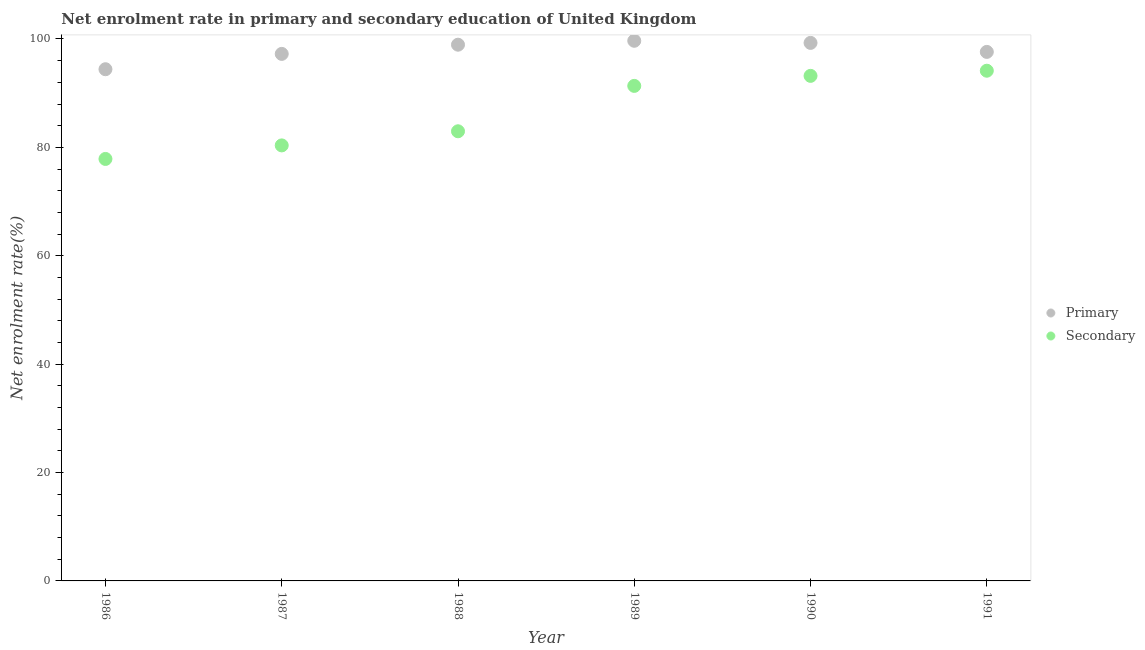How many different coloured dotlines are there?
Make the answer very short. 2. What is the enrollment rate in primary education in 1986?
Your response must be concise. 94.42. Across all years, what is the maximum enrollment rate in secondary education?
Give a very brief answer. 94.14. Across all years, what is the minimum enrollment rate in secondary education?
Keep it short and to the point. 77.86. What is the total enrollment rate in secondary education in the graph?
Provide a succinct answer. 519.88. What is the difference between the enrollment rate in secondary education in 1986 and that in 1988?
Keep it short and to the point. -5.11. What is the difference between the enrollment rate in secondary education in 1988 and the enrollment rate in primary education in 1991?
Offer a very short reply. -14.65. What is the average enrollment rate in secondary education per year?
Give a very brief answer. 86.65. In the year 1990, what is the difference between the enrollment rate in secondary education and enrollment rate in primary education?
Your response must be concise. -6.08. In how many years, is the enrollment rate in secondary education greater than 92 %?
Provide a short and direct response. 2. What is the ratio of the enrollment rate in secondary education in 1988 to that in 1989?
Offer a terse response. 0.91. Is the enrollment rate in secondary education in 1988 less than that in 1991?
Your answer should be very brief. Yes. Is the difference between the enrollment rate in primary education in 1988 and 1990 greater than the difference between the enrollment rate in secondary education in 1988 and 1990?
Your answer should be compact. Yes. What is the difference between the highest and the second highest enrollment rate in secondary education?
Give a very brief answer. 0.95. What is the difference between the highest and the lowest enrollment rate in secondary education?
Make the answer very short. 16.28. In how many years, is the enrollment rate in primary education greater than the average enrollment rate in primary education taken over all years?
Provide a succinct answer. 3. Is the sum of the enrollment rate in primary education in 1986 and 1987 greater than the maximum enrollment rate in secondary education across all years?
Offer a terse response. Yes. Is the enrollment rate in primary education strictly greater than the enrollment rate in secondary education over the years?
Provide a short and direct response. Yes. Is the enrollment rate in primary education strictly less than the enrollment rate in secondary education over the years?
Your answer should be compact. No. Does the graph contain grids?
Keep it short and to the point. No. Where does the legend appear in the graph?
Provide a short and direct response. Center right. What is the title of the graph?
Give a very brief answer. Net enrolment rate in primary and secondary education of United Kingdom. Does "Merchandise exports" appear as one of the legend labels in the graph?
Your answer should be very brief. No. What is the label or title of the Y-axis?
Ensure brevity in your answer.  Net enrolment rate(%). What is the Net enrolment rate(%) in Primary in 1986?
Provide a succinct answer. 94.42. What is the Net enrolment rate(%) of Secondary in 1986?
Provide a succinct answer. 77.86. What is the Net enrolment rate(%) of Primary in 1987?
Your answer should be compact. 97.25. What is the Net enrolment rate(%) of Secondary in 1987?
Provide a succinct answer. 80.36. What is the Net enrolment rate(%) in Primary in 1988?
Keep it short and to the point. 98.95. What is the Net enrolment rate(%) in Secondary in 1988?
Provide a short and direct response. 82.97. What is the Net enrolment rate(%) in Primary in 1989?
Give a very brief answer. 99.67. What is the Net enrolment rate(%) in Secondary in 1989?
Provide a succinct answer. 91.34. What is the Net enrolment rate(%) of Primary in 1990?
Your answer should be compact. 99.28. What is the Net enrolment rate(%) in Secondary in 1990?
Provide a succinct answer. 93.19. What is the Net enrolment rate(%) of Primary in 1991?
Make the answer very short. 97.62. What is the Net enrolment rate(%) of Secondary in 1991?
Make the answer very short. 94.14. Across all years, what is the maximum Net enrolment rate(%) of Primary?
Keep it short and to the point. 99.67. Across all years, what is the maximum Net enrolment rate(%) in Secondary?
Offer a terse response. 94.14. Across all years, what is the minimum Net enrolment rate(%) of Primary?
Give a very brief answer. 94.42. Across all years, what is the minimum Net enrolment rate(%) of Secondary?
Your answer should be compact. 77.86. What is the total Net enrolment rate(%) in Primary in the graph?
Offer a terse response. 587.18. What is the total Net enrolment rate(%) of Secondary in the graph?
Provide a short and direct response. 519.88. What is the difference between the Net enrolment rate(%) in Primary in 1986 and that in 1987?
Give a very brief answer. -2.83. What is the difference between the Net enrolment rate(%) of Secondary in 1986 and that in 1987?
Your answer should be very brief. -2.5. What is the difference between the Net enrolment rate(%) in Primary in 1986 and that in 1988?
Provide a succinct answer. -4.53. What is the difference between the Net enrolment rate(%) in Secondary in 1986 and that in 1988?
Give a very brief answer. -5.11. What is the difference between the Net enrolment rate(%) of Primary in 1986 and that in 1989?
Keep it short and to the point. -5.25. What is the difference between the Net enrolment rate(%) in Secondary in 1986 and that in 1989?
Make the answer very short. -13.48. What is the difference between the Net enrolment rate(%) of Primary in 1986 and that in 1990?
Your answer should be compact. -4.86. What is the difference between the Net enrolment rate(%) in Secondary in 1986 and that in 1990?
Ensure brevity in your answer.  -15.33. What is the difference between the Net enrolment rate(%) in Primary in 1986 and that in 1991?
Provide a succinct answer. -3.2. What is the difference between the Net enrolment rate(%) of Secondary in 1986 and that in 1991?
Your response must be concise. -16.28. What is the difference between the Net enrolment rate(%) of Primary in 1987 and that in 1988?
Provide a succinct answer. -1.7. What is the difference between the Net enrolment rate(%) in Secondary in 1987 and that in 1988?
Make the answer very short. -2.61. What is the difference between the Net enrolment rate(%) of Primary in 1987 and that in 1989?
Make the answer very short. -2.42. What is the difference between the Net enrolment rate(%) of Secondary in 1987 and that in 1989?
Offer a very short reply. -10.98. What is the difference between the Net enrolment rate(%) of Primary in 1987 and that in 1990?
Give a very brief answer. -2.03. What is the difference between the Net enrolment rate(%) of Secondary in 1987 and that in 1990?
Provide a succinct answer. -12.83. What is the difference between the Net enrolment rate(%) in Primary in 1987 and that in 1991?
Your response must be concise. -0.37. What is the difference between the Net enrolment rate(%) of Secondary in 1987 and that in 1991?
Your response must be concise. -13.78. What is the difference between the Net enrolment rate(%) in Primary in 1988 and that in 1989?
Give a very brief answer. -0.72. What is the difference between the Net enrolment rate(%) of Secondary in 1988 and that in 1989?
Provide a short and direct response. -8.37. What is the difference between the Net enrolment rate(%) of Primary in 1988 and that in 1990?
Offer a terse response. -0.33. What is the difference between the Net enrolment rate(%) in Secondary in 1988 and that in 1990?
Your response must be concise. -10.22. What is the difference between the Net enrolment rate(%) in Primary in 1988 and that in 1991?
Give a very brief answer. 1.33. What is the difference between the Net enrolment rate(%) of Secondary in 1988 and that in 1991?
Your response must be concise. -11.17. What is the difference between the Net enrolment rate(%) in Primary in 1989 and that in 1990?
Ensure brevity in your answer.  0.39. What is the difference between the Net enrolment rate(%) in Secondary in 1989 and that in 1990?
Keep it short and to the point. -1.85. What is the difference between the Net enrolment rate(%) of Primary in 1989 and that in 1991?
Your answer should be compact. 2.05. What is the difference between the Net enrolment rate(%) of Secondary in 1989 and that in 1991?
Offer a terse response. -2.8. What is the difference between the Net enrolment rate(%) of Primary in 1990 and that in 1991?
Provide a short and direct response. 1.66. What is the difference between the Net enrolment rate(%) of Secondary in 1990 and that in 1991?
Keep it short and to the point. -0.95. What is the difference between the Net enrolment rate(%) of Primary in 1986 and the Net enrolment rate(%) of Secondary in 1987?
Offer a very short reply. 14.05. What is the difference between the Net enrolment rate(%) of Primary in 1986 and the Net enrolment rate(%) of Secondary in 1988?
Offer a terse response. 11.45. What is the difference between the Net enrolment rate(%) in Primary in 1986 and the Net enrolment rate(%) in Secondary in 1989?
Ensure brevity in your answer.  3.07. What is the difference between the Net enrolment rate(%) in Primary in 1986 and the Net enrolment rate(%) in Secondary in 1990?
Make the answer very short. 1.22. What is the difference between the Net enrolment rate(%) of Primary in 1986 and the Net enrolment rate(%) of Secondary in 1991?
Give a very brief answer. 0.27. What is the difference between the Net enrolment rate(%) in Primary in 1987 and the Net enrolment rate(%) in Secondary in 1988?
Your answer should be compact. 14.28. What is the difference between the Net enrolment rate(%) in Primary in 1987 and the Net enrolment rate(%) in Secondary in 1989?
Your response must be concise. 5.91. What is the difference between the Net enrolment rate(%) in Primary in 1987 and the Net enrolment rate(%) in Secondary in 1990?
Give a very brief answer. 4.05. What is the difference between the Net enrolment rate(%) of Primary in 1987 and the Net enrolment rate(%) of Secondary in 1991?
Your answer should be very brief. 3.11. What is the difference between the Net enrolment rate(%) of Primary in 1988 and the Net enrolment rate(%) of Secondary in 1989?
Ensure brevity in your answer.  7.6. What is the difference between the Net enrolment rate(%) of Primary in 1988 and the Net enrolment rate(%) of Secondary in 1990?
Give a very brief answer. 5.75. What is the difference between the Net enrolment rate(%) of Primary in 1988 and the Net enrolment rate(%) of Secondary in 1991?
Your answer should be compact. 4.8. What is the difference between the Net enrolment rate(%) of Primary in 1989 and the Net enrolment rate(%) of Secondary in 1990?
Your answer should be very brief. 6.47. What is the difference between the Net enrolment rate(%) of Primary in 1989 and the Net enrolment rate(%) of Secondary in 1991?
Your answer should be compact. 5.52. What is the difference between the Net enrolment rate(%) in Primary in 1990 and the Net enrolment rate(%) in Secondary in 1991?
Ensure brevity in your answer.  5.13. What is the average Net enrolment rate(%) in Primary per year?
Keep it short and to the point. 97.86. What is the average Net enrolment rate(%) of Secondary per year?
Your response must be concise. 86.65. In the year 1986, what is the difference between the Net enrolment rate(%) in Primary and Net enrolment rate(%) in Secondary?
Ensure brevity in your answer.  16.55. In the year 1987, what is the difference between the Net enrolment rate(%) in Primary and Net enrolment rate(%) in Secondary?
Ensure brevity in your answer.  16.89. In the year 1988, what is the difference between the Net enrolment rate(%) of Primary and Net enrolment rate(%) of Secondary?
Give a very brief answer. 15.98. In the year 1989, what is the difference between the Net enrolment rate(%) in Primary and Net enrolment rate(%) in Secondary?
Give a very brief answer. 8.32. In the year 1990, what is the difference between the Net enrolment rate(%) in Primary and Net enrolment rate(%) in Secondary?
Your answer should be compact. 6.08. In the year 1991, what is the difference between the Net enrolment rate(%) in Primary and Net enrolment rate(%) in Secondary?
Your answer should be compact. 3.47. What is the ratio of the Net enrolment rate(%) in Primary in 1986 to that in 1987?
Your response must be concise. 0.97. What is the ratio of the Net enrolment rate(%) of Secondary in 1986 to that in 1987?
Your answer should be very brief. 0.97. What is the ratio of the Net enrolment rate(%) in Primary in 1986 to that in 1988?
Provide a succinct answer. 0.95. What is the ratio of the Net enrolment rate(%) of Secondary in 1986 to that in 1988?
Provide a succinct answer. 0.94. What is the ratio of the Net enrolment rate(%) in Primary in 1986 to that in 1989?
Keep it short and to the point. 0.95. What is the ratio of the Net enrolment rate(%) of Secondary in 1986 to that in 1989?
Your response must be concise. 0.85. What is the ratio of the Net enrolment rate(%) in Primary in 1986 to that in 1990?
Provide a short and direct response. 0.95. What is the ratio of the Net enrolment rate(%) in Secondary in 1986 to that in 1990?
Offer a very short reply. 0.84. What is the ratio of the Net enrolment rate(%) of Primary in 1986 to that in 1991?
Your response must be concise. 0.97. What is the ratio of the Net enrolment rate(%) of Secondary in 1986 to that in 1991?
Your answer should be compact. 0.83. What is the ratio of the Net enrolment rate(%) in Primary in 1987 to that in 1988?
Ensure brevity in your answer.  0.98. What is the ratio of the Net enrolment rate(%) of Secondary in 1987 to that in 1988?
Your answer should be very brief. 0.97. What is the ratio of the Net enrolment rate(%) of Primary in 1987 to that in 1989?
Make the answer very short. 0.98. What is the ratio of the Net enrolment rate(%) in Secondary in 1987 to that in 1989?
Make the answer very short. 0.88. What is the ratio of the Net enrolment rate(%) in Primary in 1987 to that in 1990?
Your answer should be very brief. 0.98. What is the ratio of the Net enrolment rate(%) of Secondary in 1987 to that in 1990?
Offer a very short reply. 0.86. What is the ratio of the Net enrolment rate(%) of Secondary in 1987 to that in 1991?
Make the answer very short. 0.85. What is the ratio of the Net enrolment rate(%) of Primary in 1988 to that in 1989?
Offer a very short reply. 0.99. What is the ratio of the Net enrolment rate(%) in Secondary in 1988 to that in 1989?
Offer a very short reply. 0.91. What is the ratio of the Net enrolment rate(%) in Secondary in 1988 to that in 1990?
Your response must be concise. 0.89. What is the ratio of the Net enrolment rate(%) of Primary in 1988 to that in 1991?
Your response must be concise. 1.01. What is the ratio of the Net enrolment rate(%) in Secondary in 1988 to that in 1991?
Make the answer very short. 0.88. What is the ratio of the Net enrolment rate(%) in Primary in 1989 to that in 1990?
Ensure brevity in your answer.  1. What is the ratio of the Net enrolment rate(%) of Secondary in 1989 to that in 1990?
Your response must be concise. 0.98. What is the ratio of the Net enrolment rate(%) of Primary in 1989 to that in 1991?
Provide a succinct answer. 1.02. What is the ratio of the Net enrolment rate(%) of Secondary in 1989 to that in 1991?
Ensure brevity in your answer.  0.97. What is the difference between the highest and the second highest Net enrolment rate(%) of Primary?
Make the answer very short. 0.39. What is the difference between the highest and the second highest Net enrolment rate(%) in Secondary?
Ensure brevity in your answer.  0.95. What is the difference between the highest and the lowest Net enrolment rate(%) of Primary?
Give a very brief answer. 5.25. What is the difference between the highest and the lowest Net enrolment rate(%) of Secondary?
Keep it short and to the point. 16.28. 